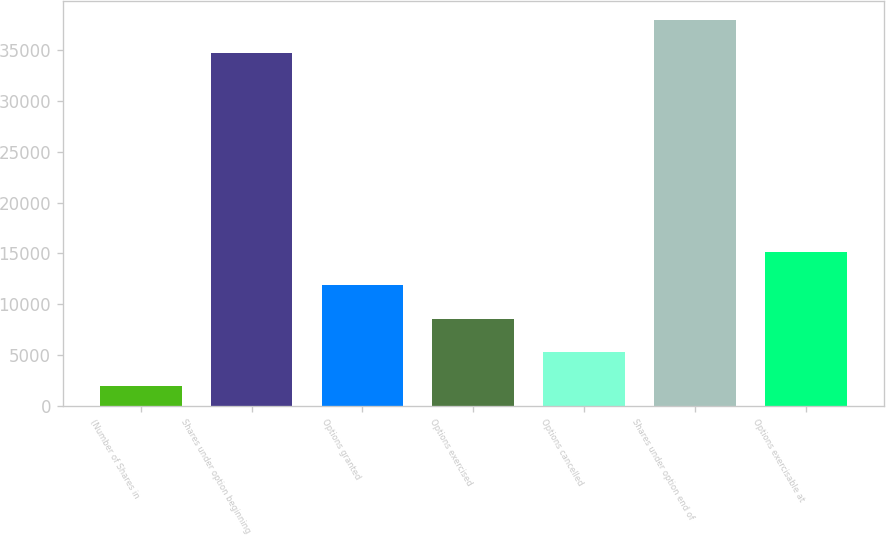Convert chart. <chart><loc_0><loc_0><loc_500><loc_500><bar_chart><fcel>(Number of Shares in<fcel>Shares under option beginning<fcel>Options granted<fcel>Options exercised<fcel>Options cancelled<fcel>Shares under option end of<fcel>Options exercisable at<nl><fcel>2000<fcel>34665<fcel>11881.7<fcel>8587.8<fcel>5293.9<fcel>37958.9<fcel>15175.6<nl></chart> 